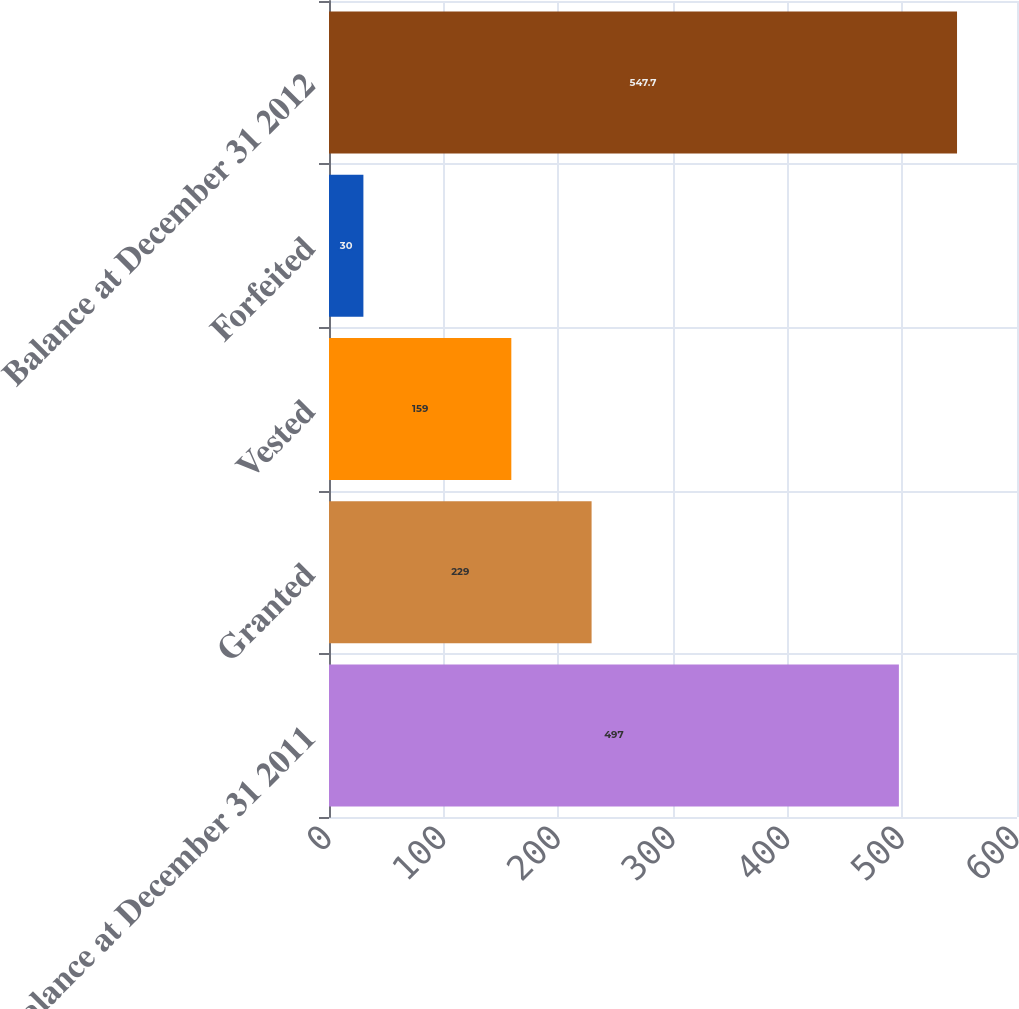Convert chart to OTSL. <chart><loc_0><loc_0><loc_500><loc_500><bar_chart><fcel>Balance at December 31 2011<fcel>Granted<fcel>Vested<fcel>Forfeited<fcel>Balance at December 31 2012<nl><fcel>497<fcel>229<fcel>159<fcel>30<fcel>547.7<nl></chart> 